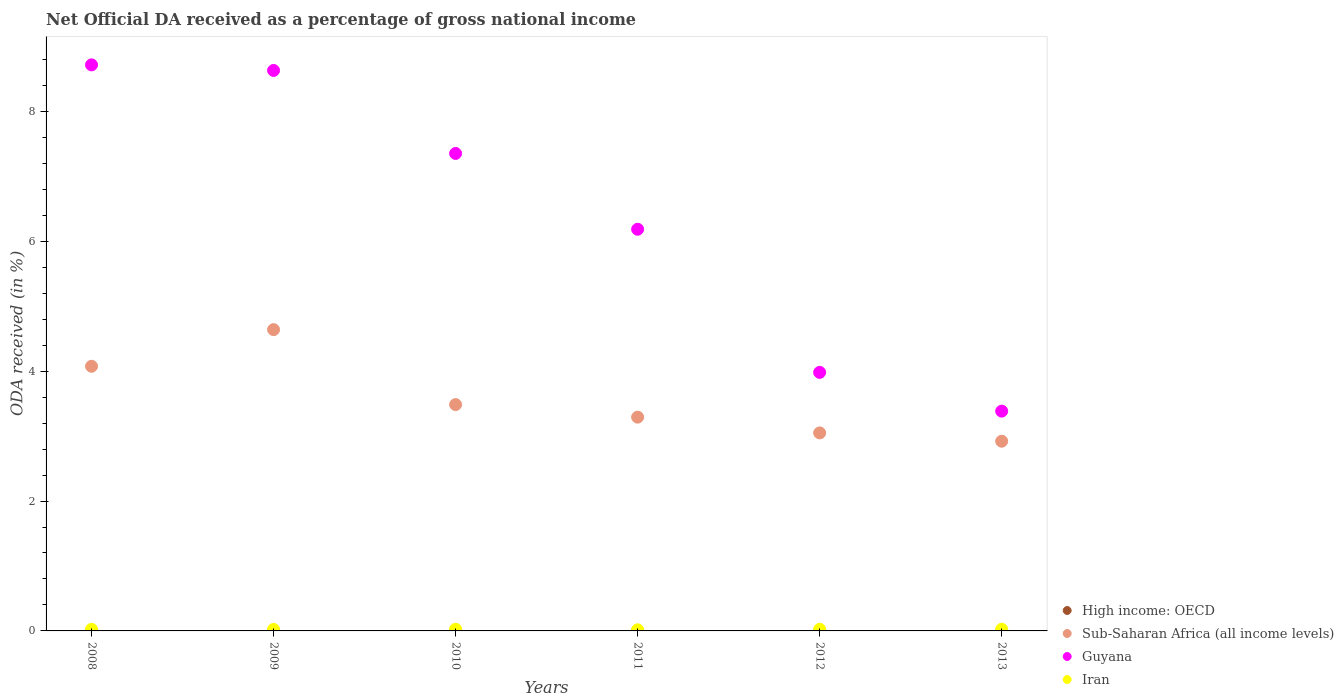What is the net official DA received in High income: OECD in 2008?
Offer a very short reply. 0. Across all years, what is the maximum net official DA received in Iran?
Provide a short and direct response. 0.03. Across all years, what is the minimum net official DA received in Sub-Saharan Africa (all income levels)?
Make the answer very short. 2.92. In which year was the net official DA received in Iran maximum?
Offer a very short reply. 2010. What is the total net official DA received in Sub-Saharan Africa (all income levels) in the graph?
Your answer should be compact. 21.46. What is the difference between the net official DA received in Sub-Saharan Africa (all income levels) in 2009 and that in 2013?
Keep it short and to the point. 1.72. What is the difference between the net official DA received in Sub-Saharan Africa (all income levels) in 2013 and the net official DA received in Guyana in 2012?
Your response must be concise. -1.06. What is the average net official DA received in Iran per year?
Your response must be concise. 0.02. In the year 2010, what is the difference between the net official DA received in Sub-Saharan Africa (all income levels) and net official DA received in Guyana?
Offer a terse response. -3.87. In how many years, is the net official DA received in Guyana greater than 1.6 %?
Make the answer very short. 6. What is the ratio of the net official DA received in High income: OECD in 2009 to that in 2012?
Your response must be concise. 0.71. Is the net official DA received in High income: OECD in 2008 less than that in 2012?
Offer a very short reply. Yes. Is the difference between the net official DA received in Sub-Saharan Africa (all income levels) in 2008 and 2011 greater than the difference between the net official DA received in Guyana in 2008 and 2011?
Make the answer very short. No. What is the difference between the highest and the second highest net official DA received in Guyana?
Keep it short and to the point. 0.09. What is the difference between the highest and the lowest net official DA received in Sub-Saharan Africa (all income levels)?
Keep it short and to the point. 1.72. Is it the case that in every year, the sum of the net official DA received in Guyana and net official DA received in Iran  is greater than the sum of net official DA received in Sub-Saharan Africa (all income levels) and net official DA received in High income: OECD?
Offer a very short reply. No. Does the net official DA received in Guyana monotonically increase over the years?
Offer a very short reply. No. Is the net official DA received in Guyana strictly less than the net official DA received in Sub-Saharan Africa (all income levels) over the years?
Provide a short and direct response. No. How many dotlines are there?
Your answer should be compact. 4. How many years are there in the graph?
Make the answer very short. 6. Are the values on the major ticks of Y-axis written in scientific E-notation?
Offer a terse response. No. Does the graph contain grids?
Offer a very short reply. No. Where does the legend appear in the graph?
Offer a terse response. Bottom right. How many legend labels are there?
Provide a short and direct response. 4. How are the legend labels stacked?
Your answer should be very brief. Vertical. What is the title of the graph?
Provide a succinct answer. Net Official DA received as a percentage of gross national income. What is the label or title of the X-axis?
Make the answer very short. Years. What is the label or title of the Y-axis?
Offer a very short reply. ODA received (in %). What is the ODA received (in %) of High income: OECD in 2008?
Keep it short and to the point. 0. What is the ODA received (in %) of Sub-Saharan Africa (all income levels) in 2008?
Give a very brief answer. 4.07. What is the ODA received (in %) in Guyana in 2008?
Provide a succinct answer. 8.72. What is the ODA received (in %) of Iran in 2008?
Keep it short and to the point. 0.02. What is the ODA received (in %) in High income: OECD in 2009?
Ensure brevity in your answer.  0. What is the ODA received (in %) in Sub-Saharan Africa (all income levels) in 2009?
Your answer should be compact. 4.64. What is the ODA received (in %) of Guyana in 2009?
Your response must be concise. 8.63. What is the ODA received (in %) of Iran in 2009?
Keep it short and to the point. 0.02. What is the ODA received (in %) of High income: OECD in 2010?
Your answer should be compact. 0. What is the ODA received (in %) in Sub-Saharan Africa (all income levels) in 2010?
Ensure brevity in your answer.  3.48. What is the ODA received (in %) in Guyana in 2010?
Offer a terse response. 7.35. What is the ODA received (in %) of Iran in 2010?
Give a very brief answer. 0.03. What is the ODA received (in %) of High income: OECD in 2011?
Your response must be concise. 0. What is the ODA received (in %) of Sub-Saharan Africa (all income levels) in 2011?
Ensure brevity in your answer.  3.29. What is the ODA received (in %) in Guyana in 2011?
Your response must be concise. 6.18. What is the ODA received (in %) of Iran in 2011?
Your answer should be compact. 0.02. What is the ODA received (in %) of High income: OECD in 2012?
Your answer should be very brief. 0. What is the ODA received (in %) in Sub-Saharan Africa (all income levels) in 2012?
Offer a very short reply. 3.05. What is the ODA received (in %) of Guyana in 2012?
Keep it short and to the point. 3.98. What is the ODA received (in %) of Iran in 2012?
Your answer should be compact. 0.03. What is the ODA received (in %) in High income: OECD in 2013?
Your answer should be very brief. 0. What is the ODA received (in %) of Sub-Saharan Africa (all income levels) in 2013?
Give a very brief answer. 2.92. What is the ODA received (in %) in Guyana in 2013?
Provide a succinct answer. 3.38. What is the ODA received (in %) of Iran in 2013?
Provide a succinct answer. 0.03. Across all years, what is the maximum ODA received (in %) in High income: OECD?
Offer a very short reply. 0. Across all years, what is the maximum ODA received (in %) of Sub-Saharan Africa (all income levels)?
Keep it short and to the point. 4.64. Across all years, what is the maximum ODA received (in %) in Guyana?
Give a very brief answer. 8.72. Across all years, what is the maximum ODA received (in %) of Iran?
Provide a succinct answer. 0.03. Across all years, what is the minimum ODA received (in %) of High income: OECD?
Offer a terse response. 0. Across all years, what is the minimum ODA received (in %) in Sub-Saharan Africa (all income levels)?
Keep it short and to the point. 2.92. Across all years, what is the minimum ODA received (in %) of Guyana?
Offer a terse response. 3.38. Across all years, what is the minimum ODA received (in %) of Iran?
Offer a terse response. 0.02. What is the total ODA received (in %) of High income: OECD in the graph?
Keep it short and to the point. 0. What is the total ODA received (in %) in Sub-Saharan Africa (all income levels) in the graph?
Offer a very short reply. 21.46. What is the total ODA received (in %) in Guyana in the graph?
Offer a very short reply. 38.25. What is the total ODA received (in %) in Iran in the graph?
Give a very brief answer. 0.14. What is the difference between the ODA received (in %) of Sub-Saharan Africa (all income levels) in 2008 and that in 2009?
Your answer should be very brief. -0.56. What is the difference between the ODA received (in %) in Guyana in 2008 and that in 2009?
Your response must be concise. 0.09. What is the difference between the ODA received (in %) of Iran in 2008 and that in 2009?
Provide a short and direct response. 0. What is the difference between the ODA received (in %) of High income: OECD in 2008 and that in 2010?
Make the answer very short. -0. What is the difference between the ODA received (in %) of Sub-Saharan Africa (all income levels) in 2008 and that in 2010?
Offer a terse response. 0.59. What is the difference between the ODA received (in %) of Guyana in 2008 and that in 2010?
Provide a succinct answer. 1.36. What is the difference between the ODA received (in %) of Iran in 2008 and that in 2010?
Offer a very short reply. -0. What is the difference between the ODA received (in %) of High income: OECD in 2008 and that in 2011?
Your response must be concise. -0. What is the difference between the ODA received (in %) in Sub-Saharan Africa (all income levels) in 2008 and that in 2011?
Your response must be concise. 0.78. What is the difference between the ODA received (in %) of Guyana in 2008 and that in 2011?
Offer a terse response. 2.53. What is the difference between the ODA received (in %) of Iran in 2008 and that in 2011?
Ensure brevity in your answer.  0.01. What is the difference between the ODA received (in %) in High income: OECD in 2008 and that in 2012?
Your answer should be very brief. -0. What is the difference between the ODA received (in %) in Sub-Saharan Africa (all income levels) in 2008 and that in 2012?
Provide a succinct answer. 1.03. What is the difference between the ODA received (in %) in Guyana in 2008 and that in 2012?
Give a very brief answer. 4.73. What is the difference between the ODA received (in %) in Iran in 2008 and that in 2012?
Your answer should be compact. -0. What is the difference between the ODA received (in %) of High income: OECD in 2008 and that in 2013?
Keep it short and to the point. 0. What is the difference between the ODA received (in %) of Sub-Saharan Africa (all income levels) in 2008 and that in 2013?
Your answer should be compact. 1.15. What is the difference between the ODA received (in %) in Guyana in 2008 and that in 2013?
Offer a very short reply. 5.33. What is the difference between the ODA received (in %) in Iran in 2008 and that in 2013?
Ensure brevity in your answer.  -0. What is the difference between the ODA received (in %) in High income: OECD in 2009 and that in 2010?
Your response must be concise. -0. What is the difference between the ODA received (in %) of Sub-Saharan Africa (all income levels) in 2009 and that in 2010?
Your answer should be very brief. 1.15. What is the difference between the ODA received (in %) in Guyana in 2009 and that in 2010?
Make the answer very short. 1.28. What is the difference between the ODA received (in %) of Iran in 2009 and that in 2010?
Your answer should be very brief. -0. What is the difference between the ODA received (in %) of High income: OECD in 2009 and that in 2011?
Make the answer very short. -0. What is the difference between the ODA received (in %) of Sub-Saharan Africa (all income levels) in 2009 and that in 2011?
Offer a terse response. 1.35. What is the difference between the ODA received (in %) of Guyana in 2009 and that in 2011?
Keep it short and to the point. 2.45. What is the difference between the ODA received (in %) of Iran in 2009 and that in 2011?
Offer a terse response. 0.01. What is the difference between the ODA received (in %) of High income: OECD in 2009 and that in 2012?
Offer a very short reply. -0. What is the difference between the ODA received (in %) of Sub-Saharan Africa (all income levels) in 2009 and that in 2012?
Ensure brevity in your answer.  1.59. What is the difference between the ODA received (in %) of Guyana in 2009 and that in 2012?
Keep it short and to the point. 4.65. What is the difference between the ODA received (in %) in Iran in 2009 and that in 2012?
Provide a succinct answer. -0. What is the difference between the ODA received (in %) of High income: OECD in 2009 and that in 2013?
Give a very brief answer. 0. What is the difference between the ODA received (in %) of Sub-Saharan Africa (all income levels) in 2009 and that in 2013?
Your answer should be very brief. 1.72. What is the difference between the ODA received (in %) of Guyana in 2009 and that in 2013?
Ensure brevity in your answer.  5.25. What is the difference between the ODA received (in %) in Iran in 2009 and that in 2013?
Your answer should be very brief. -0. What is the difference between the ODA received (in %) in Sub-Saharan Africa (all income levels) in 2010 and that in 2011?
Your response must be concise. 0.19. What is the difference between the ODA received (in %) in Guyana in 2010 and that in 2011?
Make the answer very short. 1.17. What is the difference between the ODA received (in %) in Iran in 2010 and that in 2011?
Make the answer very short. 0.01. What is the difference between the ODA received (in %) of Sub-Saharan Africa (all income levels) in 2010 and that in 2012?
Your answer should be compact. 0.44. What is the difference between the ODA received (in %) in Guyana in 2010 and that in 2012?
Give a very brief answer. 3.37. What is the difference between the ODA received (in %) in Iran in 2010 and that in 2012?
Provide a succinct answer. 0. What is the difference between the ODA received (in %) in High income: OECD in 2010 and that in 2013?
Your response must be concise. 0. What is the difference between the ODA received (in %) of Sub-Saharan Africa (all income levels) in 2010 and that in 2013?
Offer a terse response. 0.56. What is the difference between the ODA received (in %) in Guyana in 2010 and that in 2013?
Provide a succinct answer. 3.97. What is the difference between the ODA received (in %) in Iran in 2010 and that in 2013?
Your answer should be compact. 0. What is the difference between the ODA received (in %) of High income: OECD in 2011 and that in 2012?
Your response must be concise. 0. What is the difference between the ODA received (in %) of Sub-Saharan Africa (all income levels) in 2011 and that in 2012?
Ensure brevity in your answer.  0.24. What is the difference between the ODA received (in %) of Guyana in 2011 and that in 2012?
Ensure brevity in your answer.  2.2. What is the difference between the ODA received (in %) of Iran in 2011 and that in 2012?
Offer a very short reply. -0.01. What is the difference between the ODA received (in %) of Sub-Saharan Africa (all income levels) in 2011 and that in 2013?
Your response must be concise. 0.37. What is the difference between the ODA received (in %) of Guyana in 2011 and that in 2013?
Provide a succinct answer. 2.8. What is the difference between the ODA received (in %) of Iran in 2011 and that in 2013?
Offer a very short reply. -0.01. What is the difference between the ODA received (in %) in High income: OECD in 2012 and that in 2013?
Provide a succinct answer. 0. What is the difference between the ODA received (in %) in Sub-Saharan Africa (all income levels) in 2012 and that in 2013?
Make the answer very short. 0.13. What is the difference between the ODA received (in %) of Guyana in 2012 and that in 2013?
Make the answer very short. 0.6. What is the difference between the ODA received (in %) in Iran in 2012 and that in 2013?
Give a very brief answer. -0. What is the difference between the ODA received (in %) in High income: OECD in 2008 and the ODA received (in %) in Sub-Saharan Africa (all income levels) in 2009?
Ensure brevity in your answer.  -4.64. What is the difference between the ODA received (in %) in High income: OECD in 2008 and the ODA received (in %) in Guyana in 2009?
Offer a very short reply. -8.63. What is the difference between the ODA received (in %) of High income: OECD in 2008 and the ODA received (in %) of Iran in 2009?
Ensure brevity in your answer.  -0.02. What is the difference between the ODA received (in %) of Sub-Saharan Africa (all income levels) in 2008 and the ODA received (in %) of Guyana in 2009?
Keep it short and to the point. -4.55. What is the difference between the ODA received (in %) in Sub-Saharan Africa (all income levels) in 2008 and the ODA received (in %) in Iran in 2009?
Ensure brevity in your answer.  4.05. What is the difference between the ODA received (in %) in Guyana in 2008 and the ODA received (in %) in Iran in 2009?
Provide a succinct answer. 8.69. What is the difference between the ODA received (in %) of High income: OECD in 2008 and the ODA received (in %) of Sub-Saharan Africa (all income levels) in 2010?
Your answer should be very brief. -3.48. What is the difference between the ODA received (in %) in High income: OECD in 2008 and the ODA received (in %) in Guyana in 2010?
Keep it short and to the point. -7.35. What is the difference between the ODA received (in %) in High income: OECD in 2008 and the ODA received (in %) in Iran in 2010?
Keep it short and to the point. -0.03. What is the difference between the ODA received (in %) of Sub-Saharan Africa (all income levels) in 2008 and the ODA received (in %) of Guyana in 2010?
Provide a short and direct response. -3.28. What is the difference between the ODA received (in %) of Sub-Saharan Africa (all income levels) in 2008 and the ODA received (in %) of Iran in 2010?
Your answer should be compact. 4.05. What is the difference between the ODA received (in %) of Guyana in 2008 and the ODA received (in %) of Iran in 2010?
Offer a terse response. 8.69. What is the difference between the ODA received (in %) in High income: OECD in 2008 and the ODA received (in %) in Sub-Saharan Africa (all income levels) in 2011?
Ensure brevity in your answer.  -3.29. What is the difference between the ODA received (in %) of High income: OECD in 2008 and the ODA received (in %) of Guyana in 2011?
Make the answer very short. -6.18. What is the difference between the ODA received (in %) of High income: OECD in 2008 and the ODA received (in %) of Iran in 2011?
Make the answer very short. -0.02. What is the difference between the ODA received (in %) in Sub-Saharan Africa (all income levels) in 2008 and the ODA received (in %) in Guyana in 2011?
Give a very brief answer. -2.11. What is the difference between the ODA received (in %) in Sub-Saharan Africa (all income levels) in 2008 and the ODA received (in %) in Iran in 2011?
Your answer should be compact. 4.06. What is the difference between the ODA received (in %) in Guyana in 2008 and the ODA received (in %) in Iran in 2011?
Provide a short and direct response. 8.7. What is the difference between the ODA received (in %) in High income: OECD in 2008 and the ODA received (in %) in Sub-Saharan Africa (all income levels) in 2012?
Provide a short and direct response. -3.05. What is the difference between the ODA received (in %) of High income: OECD in 2008 and the ODA received (in %) of Guyana in 2012?
Your answer should be compact. -3.98. What is the difference between the ODA received (in %) of High income: OECD in 2008 and the ODA received (in %) of Iran in 2012?
Your answer should be very brief. -0.03. What is the difference between the ODA received (in %) of Sub-Saharan Africa (all income levels) in 2008 and the ODA received (in %) of Guyana in 2012?
Make the answer very short. 0.09. What is the difference between the ODA received (in %) in Sub-Saharan Africa (all income levels) in 2008 and the ODA received (in %) in Iran in 2012?
Your answer should be very brief. 4.05. What is the difference between the ODA received (in %) in Guyana in 2008 and the ODA received (in %) in Iran in 2012?
Your answer should be very brief. 8.69. What is the difference between the ODA received (in %) in High income: OECD in 2008 and the ODA received (in %) in Sub-Saharan Africa (all income levels) in 2013?
Make the answer very short. -2.92. What is the difference between the ODA received (in %) in High income: OECD in 2008 and the ODA received (in %) in Guyana in 2013?
Offer a very short reply. -3.38. What is the difference between the ODA received (in %) in High income: OECD in 2008 and the ODA received (in %) in Iran in 2013?
Your response must be concise. -0.03. What is the difference between the ODA received (in %) of Sub-Saharan Africa (all income levels) in 2008 and the ODA received (in %) of Guyana in 2013?
Ensure brevity in your answer.  0.69. What is the difference between the ODA received (in %) of Sub-Saharan Africa (all income levels) in 2008 and the ODA received (in %) of Iran in 2013?
Provide a short and direct response. 4.05. What is the difference between the ODA received (in %) of Guyana in 2008 and the ODA received (in %) of Iran in 2013?
Ensure brevity in your answer.  8.69. What is the difference between the ODA received (in %) in High income: OECD in 2009 and the ODA received (in %) in Sub-Saharan Africa (all income levels) in 2010?
Your response must be concise. -3.48. What is the difference between the ODA received (in %) of High income: OECD in 2009 and the ODA received (in %) of Guyana in 2010?
Your answer should be very brief. -7.35. What is the difference between the ODA received (in %) of High income: OECD in 2009 and the ODA received (in %) of Iran in 2010?
Your response must be concise. -0.03. What is the difference between the ODA received (in %) of Sub-Saharan Africa (all income levels) in 2009 and the ODA received (in %) of Guyana in 2010?
Your answer should be very brief. -2.71. What is the difference between the ODA received (in %) of Sub-Saharan Africa (all income levels) in 2009 and the ODA received (in %) of Iran in 2010?
Offer a very short reply. 4.61. What is the difference between the ODA received (in %) of Guyana in 2009 and the ODA received (in %) of Iran in 2010?
Your answer should be compact. 8.6. What is the difference between the ODA received (in %) in High income: OECD in 2009 and the ODA received (in %) in Sub-Saharan Africa (all income levels) in 2011?
Your answer should be compact. -3.29. What is the difference between the ODA received (in %) in High income: OECD in 2009 and the ODA received (in %) in Guyana in 2011?
Offer a terse response. -6.18. What is the difference between the ODA received (in %) of High income: OECD in 2009 and the ODA received (in %) of Iran in 2011?
Offer a very short reply. -0.02. What is the difference between the ODA received (in %) in Sub-Saharan Africa (all income levels) in 2009 and the ODA received (in %) in Guyana in 2011?
Offer a very short reply. -1.55. What is the difference between the ODA received (in %) in Sub-Saharan Africa (all income levels) in 2009 and the ODA received (in %) in Iran in 2011?
Your answer should be very brief. 4.62. What is the difference between the ODA received (in %) of Guyana in 2009 and the ODA received (in %) of Iran in 2011?
Your answer should be compact. 8.61. What is the difference between the ODA received (in %) of High income: OECD in 2009 and the ODA received (in %) of Sub-Saharan Africa (all income levels) in 2012?
Ensure brevity in your answer.  -3.05. What is the difference between the ODA received (in %) in High income: OECD in 2009 and the ODA received (in %) in Guyana in 2012?
Your answer should be very brief. -3.98. What is the difference between the ODA received (in %) of High income: OECD in 2009 and the ODA received (in %) of Iran in 2012?
Your answer should be compact. -0.03. What is the difference between the ODA received (in %) in Sub-Saharan Africa (all income levels) in 2009 and the ODA received (in %) in Guyana in 2012?
Your answer should be compact. 0.66. What is the difference between the ODA received (in %) in Sub-Saharan Africa (all income levels) in 2009 and the ODA received (in %) in Iran in 2012?
Provide a short and direct response. 4.61. What is the difference between the ODA received (in %) of Guyana in 2009 and the ODA received (in %) of Iran in 2012?
Provide a short and direct response. 8.6. What is the difference between the ODA received (in %) of High income: OECD in 2009 and the ODA received (in %) of Sub-Saharan Africa (all income levels) in 2013?
Offer a very short reply. -2.92. What is the difference between the ODA received (in %) in High income: OECD in 2009 and the ODA received (in %) in Guyana in 2013?
Your answer should be very brief. -3.38. What is the difference between the ODA received (in %) of High income: OECD in 2009 and the ODA received (in %) of Iran in 2013?
Ensure brevity in your answer.  -0.03. What is the difference between the ODA received (in %) of Sub-Saharan Africa (all income levels) in 2009 and the ODA received (in %) of Guyana in 2013?
Give a very brief answer. 1.25. What is the difference between the ODA received (in %) in Sub-Saharan Africa (all income levels) in 2009 and the ODA received (in %) in Iran in 2013?
Your response must be concise. 4.61. What is the difference between the ODA received (in %) of Guyana in 2009 and the ODA received (in %) of Iran in 2013?
Offer a very short reply. 8.6. What is the difference between the ODA received (in %) in High income: OECD in 2010 and the ODA received (in %) in Sub-Saharan Africa (all income levels) in 2011?
Keep it short and to the point. -3.29. What is the difference between the ODA received (in %) of High income: OECD in 2010 and the ODA received (in %) of Guyana in 2011?
Give a very brief answer. -6.18. What is the difference between the ODA received (in %) of High income: OECD in 2010 and the ODA received (in %) of Iran in 2011?
Provide a succinct answer. -0.02. What is the difference between the ODA received (in %) in Sub-Saharan Africa (all income levels) in 2010 and the ODA received (in %) in Guyana in 2011?
Your answer should be compact. -2.7. What is the difference between the ODA received (in %) in Sub-Saharan Africa (all income levels) in 2010 and the ODA received (in %) in Iran in 2011?
Your response must be concise. 3.47. What is the difference between the ODA received (in %) in Guyana in 2010 and the ODA received (in %) in Iran in 2011?
Provide a succinct answer. 7.33. What is the difference between the ODA received (in %) of High income: OECD in 2010 and the ODA received (in %) of Sub-Saharan Africa (all income levels) in 2012?
Keep it short and to the point. -3.05. What is the difference between the ODA received (in %) of High income: OECD in 2010 and the ODA received (in %) of Guyana in 2012?
Your response must be concise. -3.98. What is the difference between the ODA received (in %) in High income: OECD in 2010 and the ODA received (in %) in Iran in 2012?
Ensure brevity in your answer.  -0.02. What is the difference between the ODA received (in %) of Sub-Saharan Africa (all income levels) in 2010 and the ODA received (in %) of Guyana in 2012?
Provide a short and direct response. -0.5. What is the difference between the ODA received (in %) in Sub-Saharan Africa (all income levels) in 2010 and the ODA received (in %) in Iran in 2012?
Offer a very short reply. 3.46. What is the difference between the ODA received (in %) in Guyana in 2010 and the ODA received (in %) in Iran in 2012?
Offer a terse response. 7.33. What is the difference between the ODA received (in %) of High income: OECD in 2010 and the ODA received (in %) of Sub-Saharan Africa (all income levels) in 2013?
Keep it short and to the point. -2.92. What is the difference between the ODA received (in %) of High income: OECD in 2010 and the ODA received (in %) of Guyana in 2013?
Your response must be concise. -3.38. What is the difference between the ODA received (in %) of High income: OECD in 2010 and the ODA received (in %) of Iran in 2013?
Give a very brief answer. -0.03. What is the difference between the ODA received (in %) of Sub-Saharan Africa (all income levels) in 2010 and the ODA received (in %) of Guyana in 2013?
Provide a succinct answer. 0.1. What is the difference between the ODA received (in %) of Sub-Saharan Africa (all income levels) in 2010 and the ODA received (in %) of Iran in 2013?
Ensure brevity in your answer.  3.46. What is the difference between the ODA received (in %) in Guyana in 2010 and the ODA received (in %) in Iran in 2013?
Your response must be concise. 7.33. What is the difference between the ODA received (in %) of High income: OECD in 2011 and the ODA received (in %) of Sub-Saharan Africa (all income levels) in 2012?
Make the answer very short. -3.05. What is the difference between the ODA received (in %) in High income: OECD in 2011 and the ODA received (in %) in Guyana in 2012?
Your response must be concise. -3.98. What is the difference between the ODA received (in %) of High income: OECD in 2011 and the ODA received (in %) of Iran in 2012?
Your answer should be compact. -0.02. What is the difference between the ODA received (in %) in Sub-Saharan Africa (all income levels) in 2011 and the ODA received (in %) in Guyana in 2012?
Provide a succinct answer. -0.69. What is the difference between the ODA received (in %) in Sub-Saharan Africa (all income levels) in 2011 and the ODA received (in %) in Iran in 2012?
Offer a terse response. 3.27. What is the difference between the ODA received (in %) of Guyana in 2011 and the ODA received (in %) of Iran in 2012?
Your answer should be very brief. 6.16. What is the difference between the ODA received (in %) of High income: OECD in 2011 and the ODA received (in %) of Sub-Saharan Africa (all income levels) in 2013?
Provide a short and direct response. -2.92. What is the difference between the ODA received (in %) of High income: OECD in 2011 and the ODA received (in %) of Guyana in 2013?
Offer a terse response. -3.38. What is the difference between the ODA received (in %) of High income: OECD in 2011 and the ODA received (in %) of Iran in 2013?
Give a very brief answer. -0.03. What is the difference between the ODA received (in %) of Sub-Saharan Africa (all income levels) in 2011 and the ODA received (in %) of Guyana in 2013?
Your answer should be very brief. -0.09. What is the difference between the ODA received (in %) of Sub-Saharan Africa (all income levels) in 2011 and the ODA received (in %) of Iran in 2013?
Your answer should be compact. 3.27. What is the difference between the ODA received (in %) of Guyana in 2011 and the ODA received (in %) of Iran in 2013?
Your response must be concise. 6.16. What is the difference between the ODA received (in %) in High income: OECD in 2012 and the ODA received (in %) in Sub-Saharan Africa (all income levels) in 2013?
Provide a short and direct response. -2.92. What is the difference between the ODA received (in %) of High income: OECD in 2012 and the ODA received (in %) of Guyana in 2013?
Your response must be concise. -3.38. What is the difference between the ODA received (in %) of High income: OECD in 2012 and the ODA received (in %) of Iran in 2013?
Provide a short and direct response. -0.03. What is the difference between the ODA received (in %) in Sub-Saharan Africa (all income levels) in 2012 and the ODA received (in %) in Guyana in 2013?
Ensure brevity in your answer.  -0.34. What is the difference between the ODA received (in %) of Sub-Saharan Africa (all income levels) in 2012 and the ODA received (in %) of Iran in 2013?
Offer a very short reply. 3.02. What is the difference between the ODA received (in %) in Guyana in 2012 and the ODA received (in %) in Iran in 2013?
Keep it short and to the point. 3.96. What is the average ODA received (in %) in High income: OECD per year?
Offer a very short reply. 0. What is the average ODA received (in %) of Sub-Saharan Africa (all income levels) per year?
Offer a terse response. 3.58. What is the average ODA received (in %) in Guyana per year?
Provide a short and direct response. 6.37. What is the average ODA received (in %) in Iran per year?
Your answer should be compact. 0.02. In the year 2008, what is the difference between the ODA received (in %) in High income: OECD and ODA received (in %) in Sub-Saharan Africa (all income levels)?
Your answer should be very brief. -4.07. In the year 2008, what is the difference between the ODA received (in %) of High income: OECD and ODA received (in %) of Guyana?
Offer a very short reply. -8.71. In the year 2008, what is the difference between the ODA received (in %) in High income: OECD and ODA received (in %) in Iran?
Offer a very short reply. -0.02. In the year 2008, what is the difference between the ODA received (in %) of Sub-Saharan Africa (all income levels) and ODA received (in %) of Guyana?
Provide a succinct answer. -4.64. In the year 2008, what is the difference between the ODA received (in %) in Sub-Saharan Africa (all income levels) and ODA received (in %) in Iran?
Your answer should be very brief. 4.05. In the year 2008, what is the difference between the ODA received (in %) of Guyana and ODA received (in %) of Iran?
Keep it short and to the point. 8.69. In the year 2009, what is the difference between the ODA received (in %) in High income: OECD and ODA received (in %) in Sub-Saharan Africa (all income levels)?
Keep it short and to the point. -4.64. In the year 2009, what is the difference between the ODA received (in %) in High income: OECD and ODA received (in %) in Guyana?
Offer a very short reply. -8.63. In the year 2009, what is the difference between the ODA received (in %) in High income: OECD and ODA received (in %) in Iran?
Make the answer very short. -0.02. In the year 2009, what is the difference between the ODA received (in %) in Sub-Saharan Africa (all income levels) and ODA received (in %) in Guyana?
Your response must be concise. -3.99. In the year 2009, what is the difference between the ODA received (in %) in Sub-Saharan Africa (all income levels) and ODA received (in %) in Iran?
Give a very brief answer. 4.62. In the year 2009, what is the difference between the ODA received (in %) of Guyana and ODA received (in %) of Iran?
Your answer should be very brief. 8.61. In the year 2010, what is the difference between the ODA received (in %) in High income: OECD and ODA received (in %) in Sub-Saharan Africa (all income levels)?
Make the answer very short. -3.48. In the year 2010, what is the difference between the ODA received (in %) of High income: OECD and ODA received (in %) of Guyana?
Your answer should be very brief. -7.35. In the year 2010, what is the difference between the ODA received (in %) of High income: OECD and ODA received (in %) of Iran?
Your response must be concise. -0.03. In the year 2010, what is the difference between the ODA received (in %) in Sub-Saharan Africa (all income levels) and ODA received (in %) in Guyana?
Provide a succinct answer. -3.87. In the year 2010, what is the difference between the ODA received (in %) in Sub-Saharan Africa (all income levels) and ODA received (in %) in Iran?
Offer a terse response. 3.46. In the year 2010, what is the difference between the ODA received (in %) in Guyana and ODA received (in %) in Iran?
Provide a short and direct response. 7.33. In the year 2011, what is the difference between the ODA received (in %) in High income: OECD and ODA received (in %) in Sub-Saharan Africa (all income levels)?
Your answer should be compact. -3.29. In the year 2011, what is the difference between the ODA received (in %) of High income: OECD and ODA received (in %) of Guyana?
Your answer should be very brief. -6.18. In the year 2011, what is the difference between the ODA received (in %) of High income: OECD and ODA received (in %) of Iran?
Provide a succinct answer. -0.02. In the year 2011, what is the difference between the ODA received (in %) in Sub-Saharan Africa (all income levels) and ODA received (in %) in Guyana?
Make the answer very short. -2.89. In the year 2011, what is the difference between the ODA received (in %) of Sub-Saharan Africa (all income levels) and ODA received (in %) of Iran?
Make the answer very short. 3.27. In the year 2011, what is the difference between the ODA received (in %) in Guyana and ODA received (in %) in Iran?
Your answer should be very brief. 6.17. In the year 2012, what is the difference between the ODA received (in %) of High income: OECD and ODA received (in %) of Sub-Saharan Africa (all income levels)?
Offer a terse response. -3.05. In the year 2012, what is the difference between the ODA received (in %) of High income: OECD and ODA received (in %) of Guyana?
Give a very brief answer. -3.98. In the year 2012, what is the difference between the ODA received (in %) of High income: OECD and ODA received (in %) of Iran?
Offer a very short reply. -0.03. In the year 2012, what is the difference between the ODA received (in %) in Sub-Saharan Africa (all income levels) and ODA received (in %) in Guyana?
Make the answer very short. -0.93. In the year 2012, what is the difference between the ODA received (in %) of Sub-Saharan Africa (all income levels) and ODA received (in %) of Iran?
Provide a short and direct response. 3.02. In the year 2012, what is the difference between the ODA received (in %) in Guyana and ODA received (in %) in Iran?
Ensure brevity in your answer.  3.96. In the year 2013, what is the difference between the ODA received (in %) of High income: OECD and ODA received (in %) of Sub-Saharan Africa (all income levels)?
Offer a very short reply. -2.92. In the year 2013, what is the difference between the ODA received (in %) of High income: OECD and ODA received (in %) of Guyana?
Provide a short and direct response. -3.38. In the year 2013, what is the difference between the ODA received (in %) of High income: OECD and ODA received (in %) of Iran?
Offer a very short reply. -0.03. In the year 2013, what is the difference between the ODA received (in %) in Sub-Saharan Africa (all income levels) and ODA received (in %) in Guyana?
Provide a succinct answer. -0.46. In the year 2013, what is the difference between the ODA received (in %) in Sub-Saharan Africa (all income levels) and ODA received (in %) in Iran?
Keep it short and to the point. 2.9. In the year 2013, what is the difference between the ODA received (in %) in Guyana and ODA received (in %) in Iran?
Provide a short and direct response. 3.36. What is the ratio of the ODA received (in %) in High income: OECD in 2008 to that in 2009?
Ensure brevity in your answer.  1.29. What is the ratio of the ODA received (in %) of Sub-Saharan Africa (all income levels) in 2008 to that in 2009?
Your answer should be very brief. 0.88. What is the ratio of the ODA received (in %) of Guyana in 2008 to that in 2009?
Your response must be concise. 1.01. What is the ratio of the ODA received (in %) of Iran in 2008 to that in 2009?
Make the answer very short. 1.07. What is the ratio of the ODA received (in %) in High income: OECD in 2008 to that in 2010?
Provide a short and direct response. 0.54. What is the ratio of the ODA received (in %) in Sub-Saharan Africa (all income levels) in 2008 to that in 2010?
Provide a succinct answer. 1.17. What is the ratio of the ODA received (in %) of Guyana in 2008 to that in 2010?
Your answer should be compact. 1.19. What is the ratio of the ODA received (in %) of Iran in 2008 to that in 2010?
Your response must be concise. 0.95. What is the ratio of the ODA received (in %) in High income: OECD in 2008 to that in 2011?
Keep it short and to the point. 0.7. What is the ratio of the ODA received (in %) in Sub-Saharan Africa (all income levels) in 2008 to that in 2011?
Your answer should be very brief. 1.24. What is the ratio of the ODA received (in %) of Guyana in 2008 to that in 2011?
Make the answer very short. 1.41. What is the ratio of the ODA received (in %) of Iran in 2008 to that in 2011?
Give a very brief answer. 1.45. What is the ratio of the ODA received (in %) in High income: OECD in 2008 to that in 2012?
Your response must be concise. 0.92. What is the ratio of the ODA received (in %) of Sub-Saharan Africa (all income levels) in 2008 to that in 2012?
Provide a succinct answer. 1.34. What is the ratio of the ODA received (in %) in Guyana in 2008 to that in 2012?
Provide a short and direct response. 2.19. What is the ratio of the ODA received (in %) in Iran in 2008 to that in 2012?
Provide a succinct answer. 0.98. What is the ratio of the ODA received (in %) in High income: OECD in 2008 to that in 2013?
Make the answer very short. 1.47. What is the ratio of the ODA received (in %) of Sub-Saharan Africa (all income levels) in 2008 to that in 2013?
Offer a terse response. 1.4. What is the ratio of the ODA received (in %) in Guyana in 2008 to that in 2013?
Provide a short and direct response. 2.58. What is the ratio of the ODA received (in %) in Iran in 2008 to that in 2013?
Your response must be concise. 0.96. What is the ratio of the ODA received (in %) in High income: OECD in 2009 to that in 2010?
Offer a very short reply. 0.42. What is the ratio of the ODA received (in %) in Sub-Saharan Africa (all income levels) in 2009 to that in 2010?
Give a very brief answer. 1.33. What is the ratio of the ODA received (in %) in Guyana in 2009 to that in 2010?
Ensure brevity in your answer.  1.17. What is the ratio of the ODA received (in %) of Iran in 2009 to that in 2010?
Make the answer very short. 0.89. What is the ratio of the ODA received (in %) in High income: OECD in 2009 to that in 2011?
Your response must be concise. 0.54. What is the ratio of the ODA received (in %) in Sub-Saharan Africa (all income levels) in 2009 to that in 2011?
Provide a short and direct response. 1.41. What is the ratio of the ODA received (in %) of Guyana in 2009 to that in 2011?
Provide a succinct answer. 1.4. What is the ratio of the ODA received (in %) in Iran in 2009 to that in 2011?
Your answer should be compact. 1.35. What is the ratio of the ODA received (in %) of High income: OECD in 2009 to that in 2012?
Provide a short and direct response. 0.71. What is the ratio of the ODA received (in %) in Sub-Saharan Africa (all income levels) in 2009 to that in 2012?
Keep it short and to the point. 1.52. What is the ratio of the ODA received (in %) of Guyana in 2009 to that in 2012?
Make the answer very short. 2.17. What is the ratio of the ODA received (in %) of Iran in 2009 to that in 2012?
Provide a succinct answer. 0.91. What is the ratio of the ODA received (in %) of High income: OECD in 2009 to that in 2013?
Your answer should be very brief. 1.14. What is the ratio of the ODA received (in %) of Sub-Saharan Africa (all income levels) in 2009 to that in 2013?
Your response must be concise. 1.59. What is the ratio of the ODA received (in %) in Guyana in 2009 to that in 2013?
Your response must be concise. 2.55. What is the ratio of the ODA received (in %) in Iran in 2009 to that in 2013?
Ensure brevity in your answer.  0.9. What is the ratio of the ODA received (in %) of High income: OECD in 2010 to that in 2011?
Keep it short and to the point. 1.3. What is the ratio of the ODA received (in %) in Sub-Saharan Africa (all income levels) in 2010 to that in 2011?
Offer a terse response. 1.06. What is the ratio of the ODA received (in %) of Guyana in 2010 to that in 2011?
Provide a short and direct response. 1.19. What is the ratio of the ODA received (in %) in Iran in 2010 to that in 2011?
Give a very brief answer. 1.52. What is the ratio of the ODA received (in %) in High income: OECD in 2010 to that in 2012?
Offer a very short reply. 1.7. What is the ratio of the ODA received (in %) of Guyana in 2010 to that in 2012?
Give a very brief answer. 1.85. What is the ratio of the ODA received (in %) in Iran in 2010 to that in 2012?
Ensure brevity in your answer.  1.02. What is the ratio of the ODA received (in %) in High income: OECD in 2010 to that in 2013?
Ensure brevity in your answer.  2.73. What is the ratio of the ODA received (in %) of Sub-Saharan Africa (all income levels) in 2010 to that in 2013?
Your answer should be compact. 1.19. What is the ratio of the ODA received (in %) in Guyana in 2010 to that in 2013?
Provide a succinct answer. 2.17. What is the ratio of the ODA received (in %) in Iran in 2010 to that in 2013?
Keep it short and to the point. 1.01. What is the ratio of the ODA received (in %) of High income: OECD in 2011 to that in 2012?
Make the answer very short. 1.31. What is the ratio of the ODA received (in %) of Sub-Saharan Africa (all income levels) in 2011 to that in 2012?
Ensure brevity in your answer.  1.08. What is the ratio of the ODA received (in %) in Guyana in 2011 to that in 2012?
Ensure brevity in your answer.  1.55. What is the ratio of the ODA received (in %) in Iran in 2011 to that in 2012?
Offer a very short reply. 0.67. What is the ratio of the ODA received (in %) of High income: OECD in 2011 to that in 2013?
Offer a terse response. 2.11. What is the ratio of the ODA received (in %) of Sub-Saharan Africa (all income levels) in 2011 to that in 2013?
Keep it short and to the point. 1.13. What is the ratio of the ODA received (in %) in Guyana in 2011 to that in 2013?
Ensure brevity in your answer.  1.83. What is the ratio of the ODA received (in %) of Iran in 2011 to that in 2013?
Give a very brief answer. 0.67. What is the ratio of the ODA received (in %) in High income: OECD in 2012 to that in 2013?
Provide a succinct answer. 1.6. What is the ratio of the ODA received (in %) in Sub-Saharan Africa (all income levels) in 2012 to that in 2013?
Give a very brief answer. 1.04. What is the ratio of the ODA received (in %) in Guyana in 2012 to that in 2013?
Your response must be concise. 1.18. What is the ratio of the ODA received (in %) in Iran in 2012 to that in 2013?
Ensure brevity in your answer.  0.99. What is the difference between the highest and the second highest ODA received (in %) of High income: OECD?
Offer a very short reply. 0. What is the difference between the highest and the second highest ODA received (in %) of Sub-Saharan Africa (all income levels)?
Your response must be concise. 0.56. What is the difference between the highest and the second highest ODA received (in %) in Guyana?
Offer a terse response. 0.09. What is the difference between the highest and the lowest ODA received (in %) of Sub-Saharan Africa (all income levels)?
Keep it short and to the point. 1.72. What is the difference between the highest and the lowest ODA received (in %) of Guyana?
Provide a short and direct response. 5.33. What is the difference between the highest and the lowest ODA received (in %) in Iran?
Your response must be concise. 0.01. 